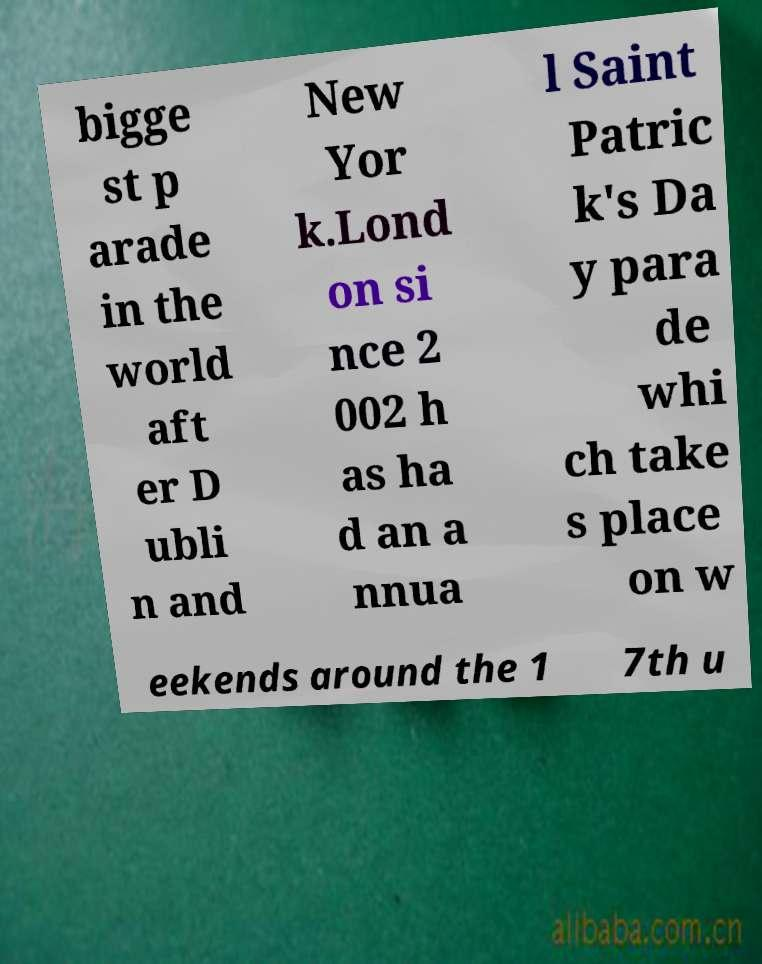What messages or text are displayed in this image? I need them in a readable, typed format. bigge st p arade in the world aft er D ubli n and New Yor k.Lond on si nce 2 002 h as ha d an a nnua l Saint Patric k's Da y para de whi ch take s place on w eekends around the 1 7th u 